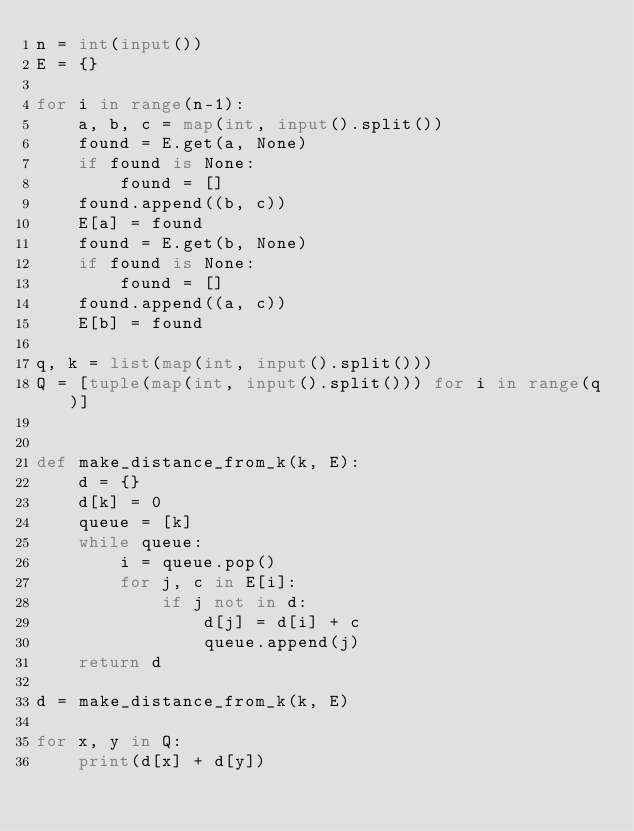<code> <loc_0><loc_0><loc_500><loc_500><_Python_>n = int(input())
E = {}

for i in range(n-1):
    a, b, c = map(int, input().split()) 
    found = E.get(a, None)
    if found is None:
        found = []
    found.append((b, c))
    E[a] = found
    found = E.get(b, None)
    if found is None:
        found = []
    found.append((a, c))
    E[b] = found

q, k = list(map(int, input().split()))
Q = [tuple(map(int, input().split())) for i in range(q)]


def make_distance_from_k(k, E):
    d = {}
    d[k] = 0
    queue = [k]
    while queue:
        i = queue.pop()
        for j, c in E[i]:
            if j not in d:
                d[j] = d[i] + c
                queue.append(j)
    return d

d = make_distance_from_k(k, E)

for x, y in Q:
    print(d[x] + d[y])
</code> 